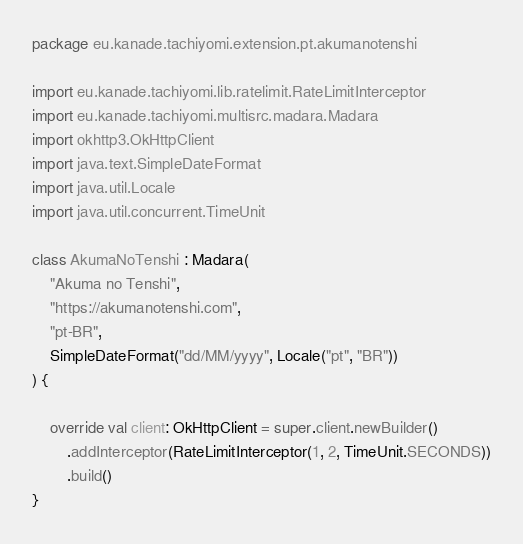Convert code to text. <code><loc_0><loc_0><loc_500><loc_500><_Kotlin_>package eu.kanade.tachiyomi.extension.pt.akumanotenshi

import eu.kanade.tachiyomi.lib.ratelimit.RateLimitInterceptor
import eu.kanade.tachiyomi.multisrc.madara.Madara
import okhttp3.OkHttpClient
import java.text.SimpleDateFormat
import java.util.Locale
import java.util.concurrent.TimeUnit

class AkumaNoTenshi : Madara(
    "Akuma no Tenshi",
    "https://akumanotenshi.com",
    "pt-BR",
    SimpleDateFormat("dd/MM/yyyy", Locale("pt", "BR"))
) {

    override val client: OkHttpClient = super.client.newBuilder()
        .addInterceptor(RateLimitInterceptor(1, 2, TimeUnit.SECONDS))
        .build()
}
</code> 